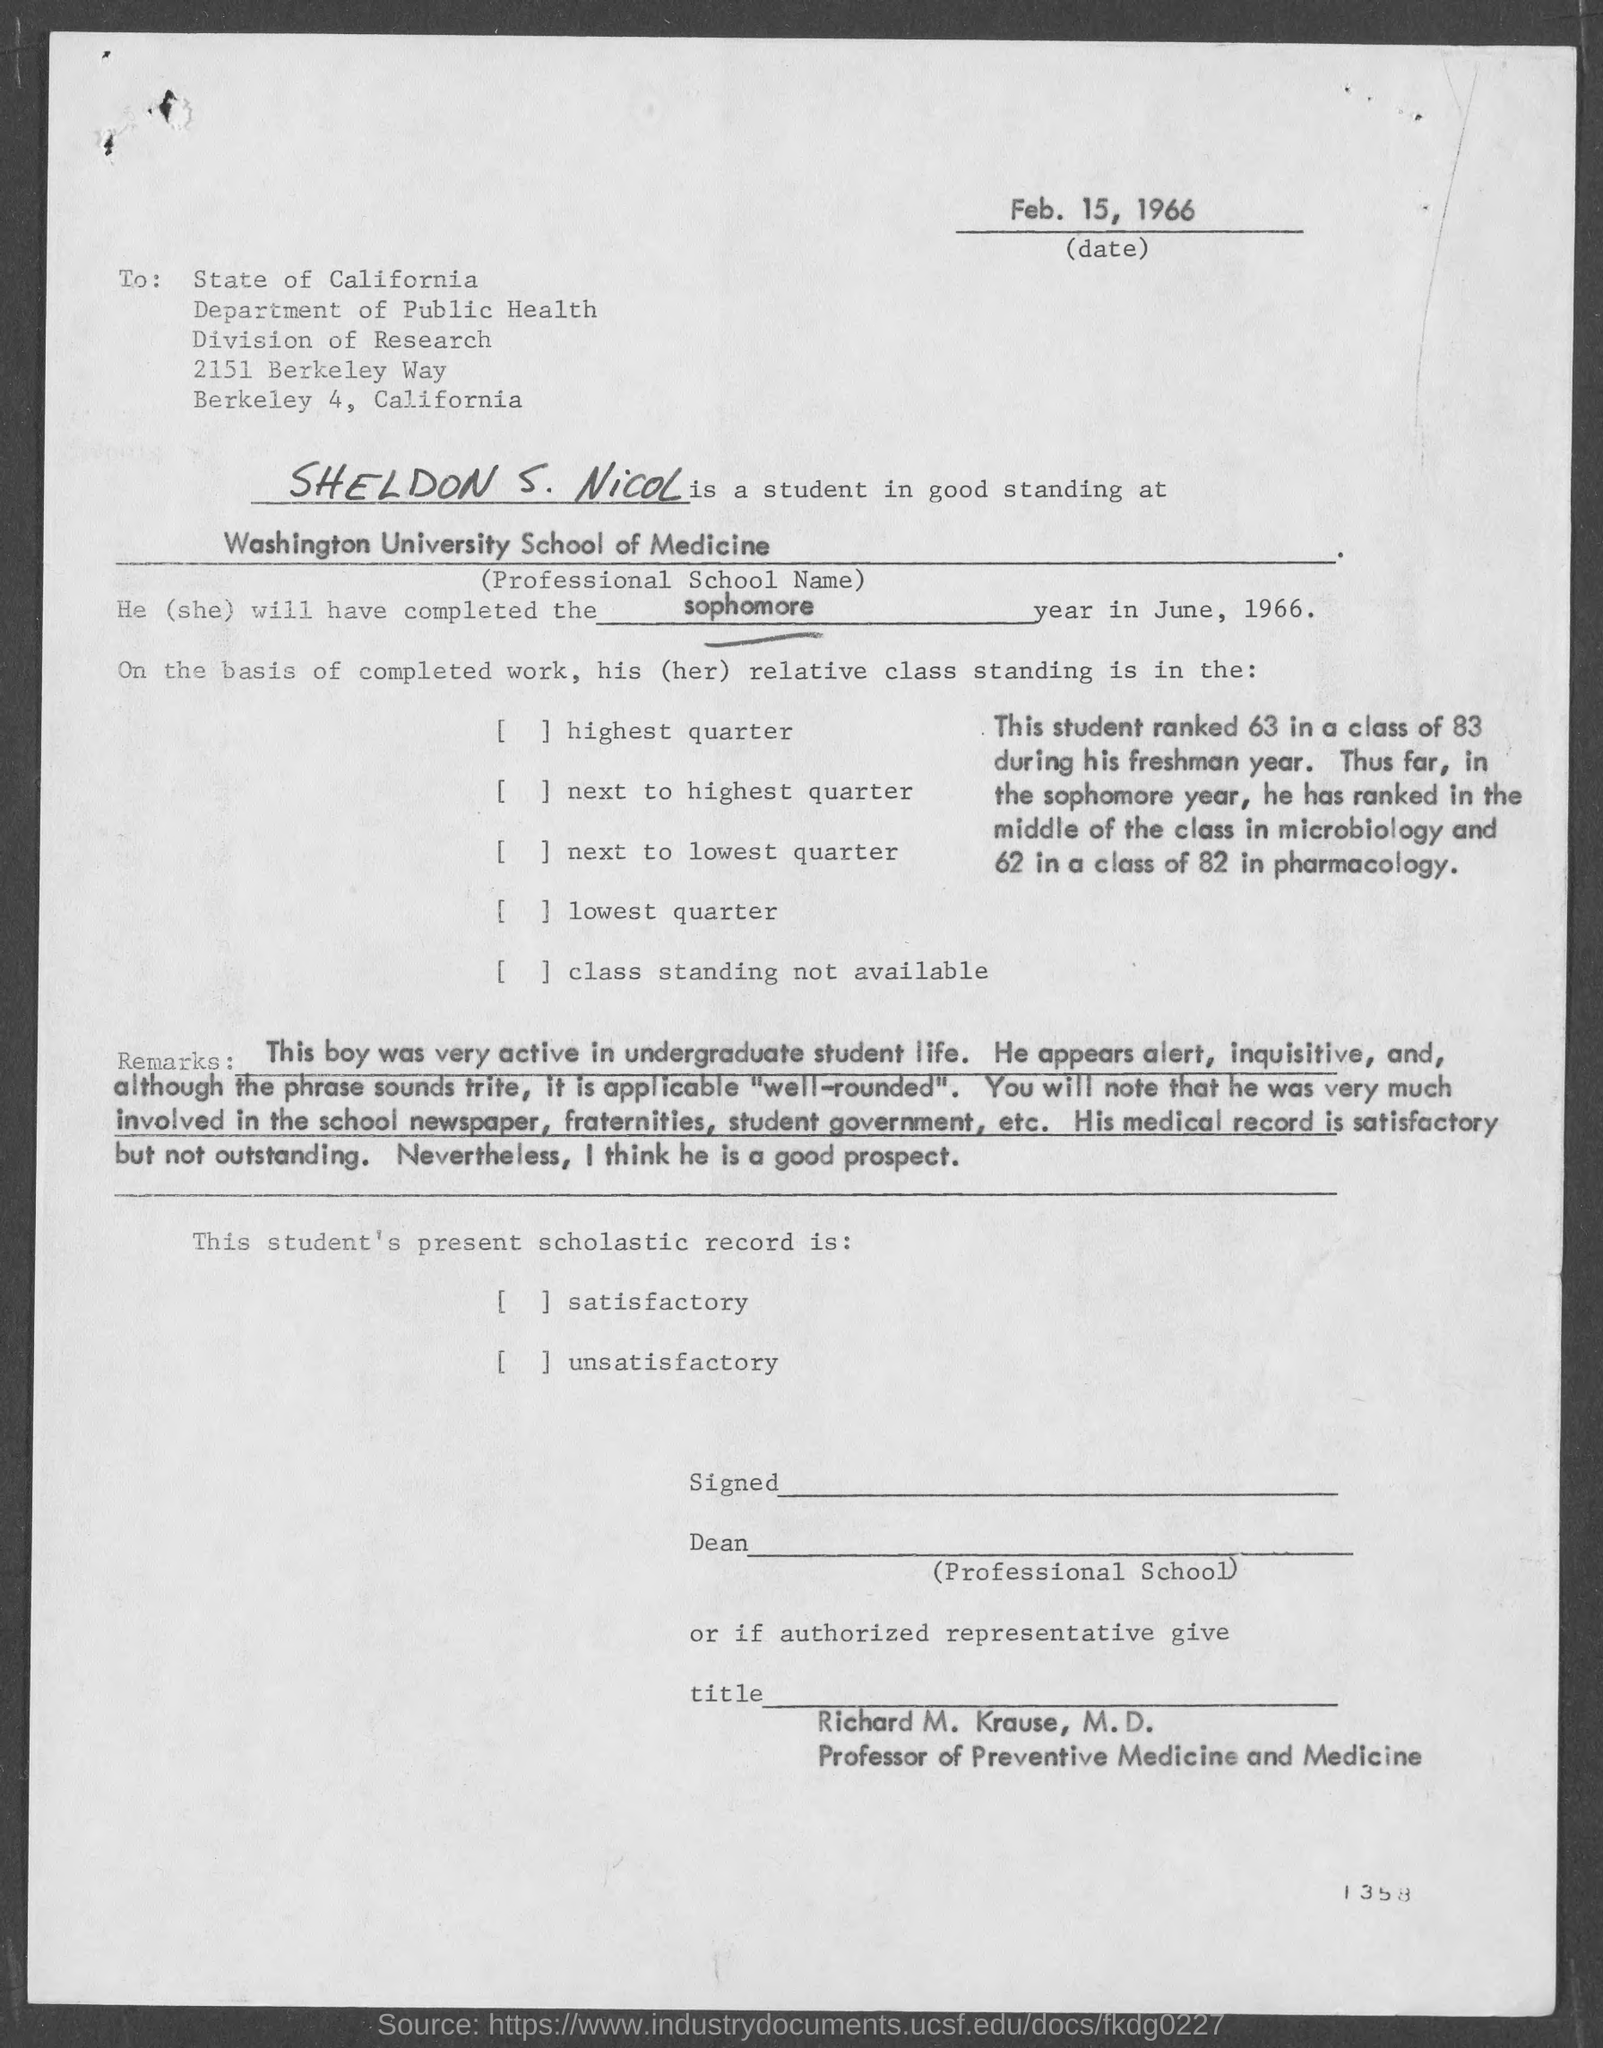Highlight a few significant elements in this photo. Sheldon will complete his sophomore year in June, 1966. Washington University School of Medicine is a highly respected professional school of medicine that is renowned for its exceptional academic programs and research opportunities. The Department of Public Health is involved in this matter. The letter is addressed to the state of California. The student will complete his sophomore year in June. 